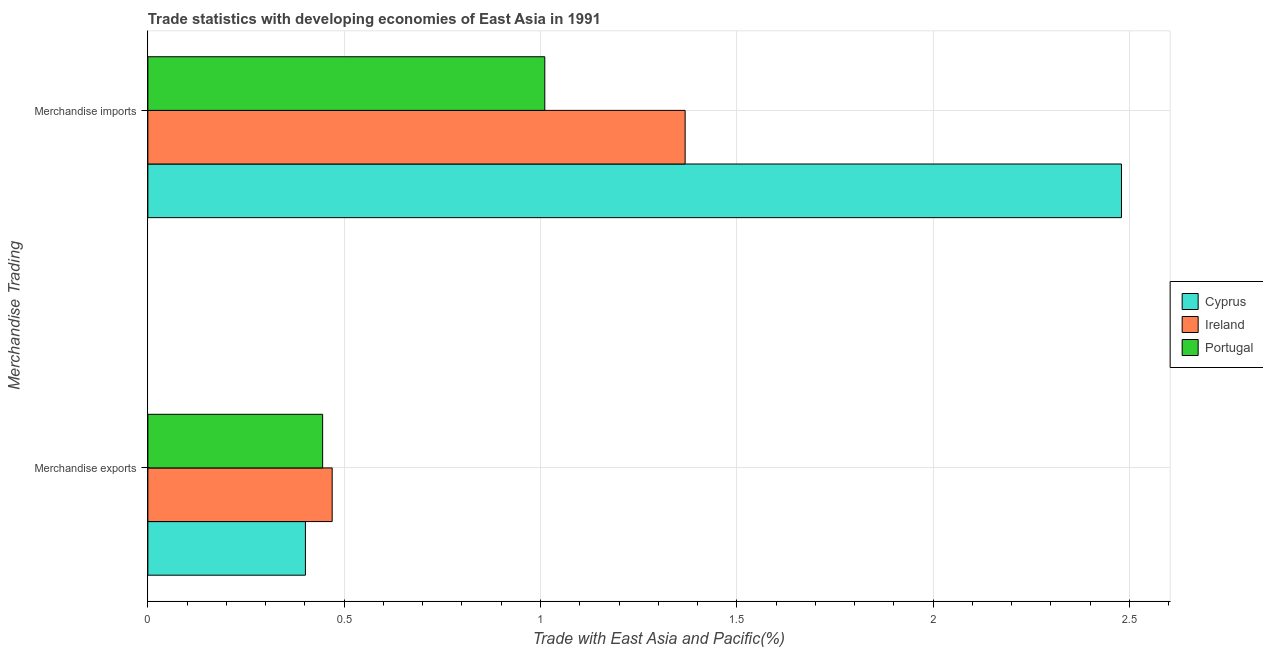How many different coloured bars are there?
Your answer should be very brief. 3. How many groups of bars are there?
Ensure brevity in your answer.  2. What is the label of the 1st group of bars from the top?
Provide a short and direct response. Merchandise imports. What is the merchandise exports in Cyprus?
Offer a very short reply. 0.4. Across all countries, what is the maximum merchandise imports?
Offer a terse response. 2.48. Across all countries, what is the minimum merchandise exports?
Provide a succinct answer. 0.4. In which country was the merchandise exports maximum?
Give a very brief answer. Ireland. What is the total merchandise exports in the graph?
Offer a terse response. 1.32. What is the difference between the merchandise exports in Ireland and that in Portugal?
Offer a very short reply. 0.02. What is the difference between the merchandise imports in Cyprus and the merchandise exports in Portugal?
Your answer should be very brief. 2.03. What is the average merchandise imports per country?
Your response must be concise. 1.62. What is the difference between the merchandise exports and merchandise imports in Cyprus?
Make the answer very short. -2.08. What is the ratio of the merchandise exports in Cyprus to that in Ireland?
Make the answer very short. 0.85. Is the merchandise imports in Portugal less than that in Ireland?
Give a very brief answer. Yes. What does the 1st bar from the top in Merchandise imports represents?
Offer a terse response. Portugal. What does the 2nd bar from the bottom in Merchandise exports represents?
Provide a short and direct response. Ireland. How many bars are there?
Offer a very short reply. 6. How many countries are there in the graph?
Offer a terse response. 3. What is the difference between two consecutive major ticks on the X-axis?
Keep it short and to the point. 0.5. What is the title of the graph?
Give a very brief answer. Trade statistics with developing economies of East Asia in 1991. Does "Peru" appear as one of the legend labels in the graph?
Provide a short and direct response. No. What is the label or title of the X-axis?
Keep it short and to the point. Trade with East Asia and Pacific(%). What is the label or title of the Y-axis?
Offer a terse response. Merchandise Trading. What is the Trade with East Asia and Pacific(%) of Cyprus in Merchandise exports?
Your answer should be very brief. 0.4. What is the Trade with East Asia and Pacific(%) in Ireland in Merchandise exports?
Make the answer very short. 0.47. What is the Trade with East Asia and Pacific(%) of Portugal in Merchandise exports?
Offer a terse response. 0.45. What is the Trade with East Asia and Pacific(%) in Cyprus in Merchandise imports?
Provide a short and direct response. 2.48. What is the Trade with East Asia and Pacific(%) of Ireland in Merchandise imports?
Offer a terse response. 1.37. What is the Trade with East Asia and Pacific(%) of Portugal in Merchandise imports?
Provide a short and direct response. 1.01. Across all Merchandise Trading, what is the maximum Trade with East Asia and Pacific(%) in Cyprus?
Make the answer very short. 2.48. Across all Merchandise Trading, what is the maximum Trade with East Asia and Pacific(%) of Ireland?
Provide a succinct answer. 1.37. Across all Merchandise Trading, what is the maximum Trade with East Asia and Pacific(%) in Portugal?
Offer a very short reply. 1.01. Across all Merchandise Trading, what is the minimum Trade with East Asia and Pacific(%) in Cyprus?
Provide a short and direct response. 0.4. Across all Merchandise Trading, what is the minimum Trade with East Asia and Pacific(%) of Ireland?
Keep it short and to the point. 0.47. Across all Merchandise Trading, what is the minimum Trade with East Asia and Pacific(%) in Portugal?
Your answer should be very brief. 0.45. What is the total Trade with East Asia and Pacific(%) in Cyprus in the graph?
Offer a very short reply. 2.88. What is the total Trade with East Asia and Pacific(%) of Ireland in the graph?
Your response must be concise. 1.84. What is the total Trade with East Asia and Pacific(%) in Portugal in the graph?
Provide a succinct answer. 1.46. What is the difference between the Trade with East Asia and Pacific(%) in Cyprus in Merchandise exports and that in Merchandise imports?
Provide a succinct answer. -2.08. What is the difference between the Trade with East Asia and Pacific(%) of Ireland in Merchandise exports and that in Merchandise imports?
Your answer should be very brief. -0.9. What is the difference between the Trade with East Asia and Pacific(%) in Portugal in Merchandise exports and that in Merchandise imports?
Keep it short and to the point. -0.57. What is the difference between the Trade with East Asia and Pacific(%) in Cyprus in Merchandise exports and the Trade with East Asia and Pacific(%) in Ireland in Merchandise imports?
Your response must be concise. -0.97. What is the difference between the Trade with East Asia and Pacific(%) of Cyprus in Merchandise exports and the Trade with East Asia and Pacific(%) of Portugal in Merchandise imports?
Offer a terse response. -0.61. What is the difference between the Trade with East Asia and Pacific(%) in Ireland in Merchandise exports and the Trade with East Asia and Pacific(%) in Portugal in Merchandise imports?
Your answer should be very brief. -0.54. What is the average Trade with East Asia and Pacific(%) of Cyprus per Merchandise Trading?
Your answer should be very brief. 1.44. What is the average Trade with East Asia and Pacific(%) of Ireland per Merchandise Trading?
Offer a terse response. 0.92. What is the average Trade with East Asia and Pacific(%) in Portugal per Merchandise Trading?
Provide a short and direct response. 0.73. What is the difference between the Trade with East Asia and Pacific(%) of Cyprus and Trade with East Asia and Pacific(%) of Ireland in Merchandise exports?
Offer a very short reply. -0.07. What is the difference between the Trade with East Asia and Pacific(%) in Cyprus and Trade with East Asia and Pacific(%) in Portugal in Merchandise exports?
Your answer should be compact. -0.04. What is the difference between the Trade with East Asia and Pacific(%) in Ireland and Trade with East Asia and Pacific(%) in Portugal in Merchandise exports?
Provide a succinct answer. 0.02. What is the difference between the Trade with East Asia and Pacific(%) of Cyprus and Trade with East Asia and Pacific(%) of Ireland in Merchandise imports?
Give a very brief answer. 1.11. What is the difference between the Trade with East Asia and Pacific(%) in Cyprus and Trade with East Asia and Pacific(%) in Portugal in Merchandise imports?
Make the answer very short. 1.47. What is the difference between the Trade with East Asia and Pacific(%) of Ireland and Trade with East Asia and Pacific(%) of Portugal in Merchandise imports?
Offer a very short reply. 0.36. What is the ratio of the Trade with East Asia and Pacific(%) of Cyprus in Merchandise exports to that in Merchandise imports?
Keep it short and to the point. 0.16. What is the ratio of the Trade with East Asia and Pacific(%) of Ireland in Merchandise exports to that in Merchandise imports?
Make the answer very short. 0.34. What is the ratio of the Trade with East Asia and Pacific(%) of Portugal in Merchandise exports to that in Merchandise imports?
Your response must be concise. 0.44. What is the difference between the highest and the second highest Trade with East Asia and Pacific(%) in Cyprus?
Offer a terse response. 2.08. What is the difference between the highest and the second highest Trade with East Asia and Pacific(%) in Ireland?
Offer a very short reply. 0.9. What is the difference between the highest and the second highest Trade with East Asia and Pacific(%) of Portugal?
Your answer should be compact. 0.57. What is the difference between the highest and the lowest Trade with East Asia and Pacific(%) of Cyprus?
Offer a very short reply. 2.08. What is the difference between the highest and the lowest Trade with East Asia and Pacific(%) in Ireland?
Provide a short and direct response. 0.9. What is the difference between the highest and the lowest Trade with East Asia and Pacific(%) in Portugal?
Give a very brief answer. 0.57. 